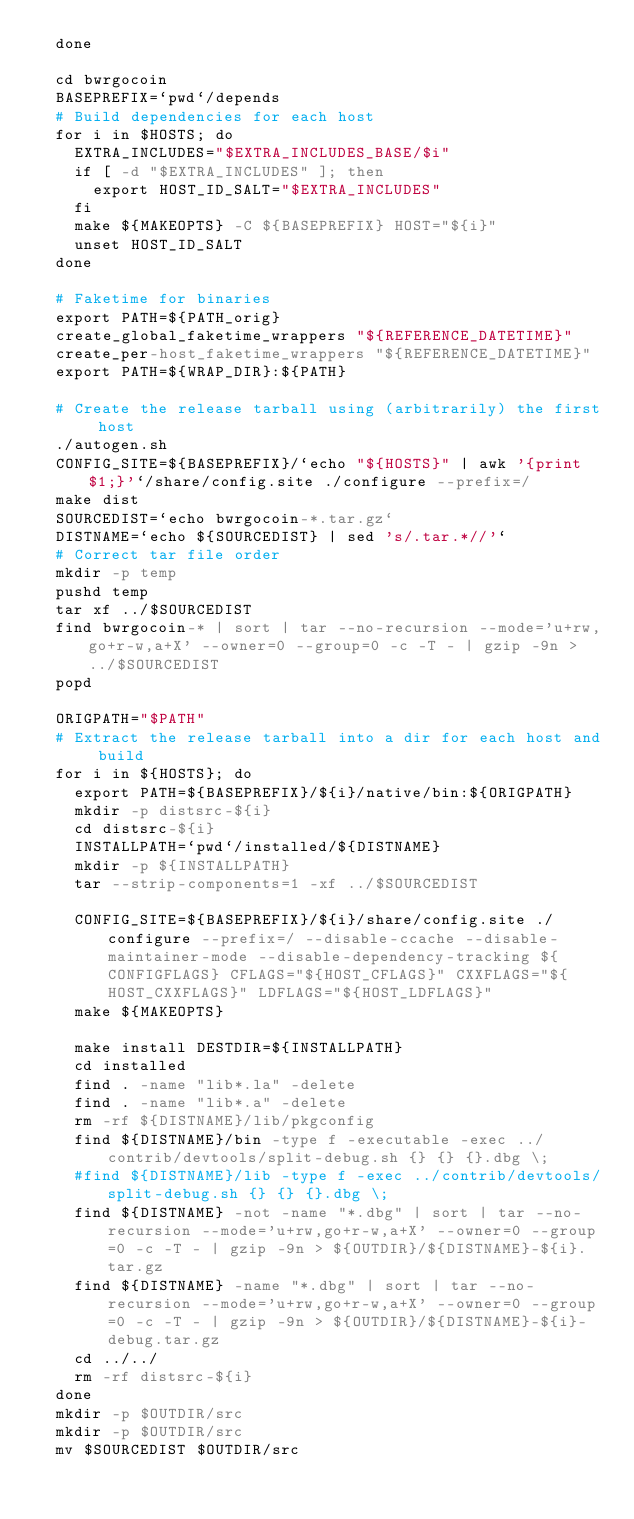Convert code to text. <code><loc_0><loc_0><loc_500><loc_500><_YAML_>  done

  cd bwrgocoin
  BASEPREFIX=`pwd`/depends
  # Build dependencies for each host
  for i in $HOSTS; do
    EXTRA_INCLUDES="$EXTRA_INCLUDES_BASE/$i"
    if [ -d "$EXTRA_INCLUDES" ]; then
      export HOST_ID_SALT="$EXTRA_INCLUDES"
    fi
    make ${MAKEOPTS} -C ${BASEPREFIX} HOST="${i}"
    unset HOST_ID_SALT
  done

  # Faketime for binaries
  export PATH=${PATH_orig}
  create_global_faketime_wrappers "${REFERENCE_DATETIME}"
  create_per-host_faketime_wrappers "${REFERENCE_DATETIME}"
  export PATH=${WRAP_DIR}:${PATH}

  # Create the release tarball using (arbitrarily) the first host
  ./autogen.sh
  CONFIG_SITE=${BASEPREFIX}/`echo "${HOSTS}" | awk '{print $1;}'`/share/config.site ./configure --prefix=/
  make dist
  SOURCEDIST=`echo bwrgocoin-*.tar.gz`
  DISTNAME=`echo ${SOURCEDIST} | sed 's/.tar.*//'`
  # Correct tar file order
  mkdir -p temp
  pushd temp
  tar xf ../$SOURCEDIST
  find bwrgocoin-* | sort | tar --no-recursion --mode='u+rw,go+r-w,a+X' --owner=0 --group=0 -c -T - | gzip -9n > ../$SOURCEDIST
  popd

  ORIGPATH="$PATH"
  # Extract the release tarball into a dir for each host and build
  for i in ${HOSTS}; do
    export PATH=${BASEPREFIX}/${i}/native/bin:${ORIGPATH}
    mkdir -p distsrc-${i}
    cd distsrc-${i}
    INSTALLPATH=`pwd`/installed/${DISTNAME}
    mkdir -p ${INSTALLPATH}
    tar --strip-components=1 -xf ../$SOURCEDIST

    CONFIG_SITE=${BASEPREFIX}/${i}/share/config.site ./configure --prefix=/ --disable-ccache --disable-maintainer-mode --disable-dependency-tracking ${CONFIGFLAGS} CFLAGS="${HOST_CFLAGS}" CXXFLAGS="${HOST_CXXFLAGS}" LDFLAGS="${HOST_LDFLAGS}"
    make ${MAKEOPTS}

    make install DESTDIR=${INSTALLPATH}
    cd installed
    find . -name "lib*.la" -delete
    find . -name "lib*.a" -delete
    rm -rf ${DISTNAME}/lib/pkgconfig
    find ${DISTNAME}/bin -type f -executable -exec ../contrib/devtools/split-debug.sh {} {} {}.dbg \;
    #find ${DISTNAME}/lib -type f -exec ../contrib/devtools/split-debug.sh {} {} {}.dbg \;
    find ${DISTNAME} -not -name "*.dbg" | sort | tar --no-recursion --mode='u+rw,go+r-w,a+X' --owner=0 --group=0 -c -T - | gzip -9n > ${OUTDIR}/${DISTNAME}-${i}.tar.gz
    find ${DISTNAME} -name "*.dbg" | sort | tar --no-recursion --mode='u+rw,go+r-w,a+X' --owner=0 --group=0 -c -T - | gzip -9n > ${OUTDIR}/${DISTNAME}-${i}-debug.tar.gz
    cd ../../
    rm -rf distsrc-${i}
  done
  mkdir -p $OUTDIR/src
  mkdir -p $OUTDIR/src
  mv $SOURCEDIST $OUTDIR/src
</code> 